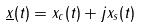Convert formula to latex. <formula><loc_0><loc_0><loc_500><loc_500>\underline { x } ( t ) = x _ { c } ( t ) + j x _ { s } ( t )</formula> 